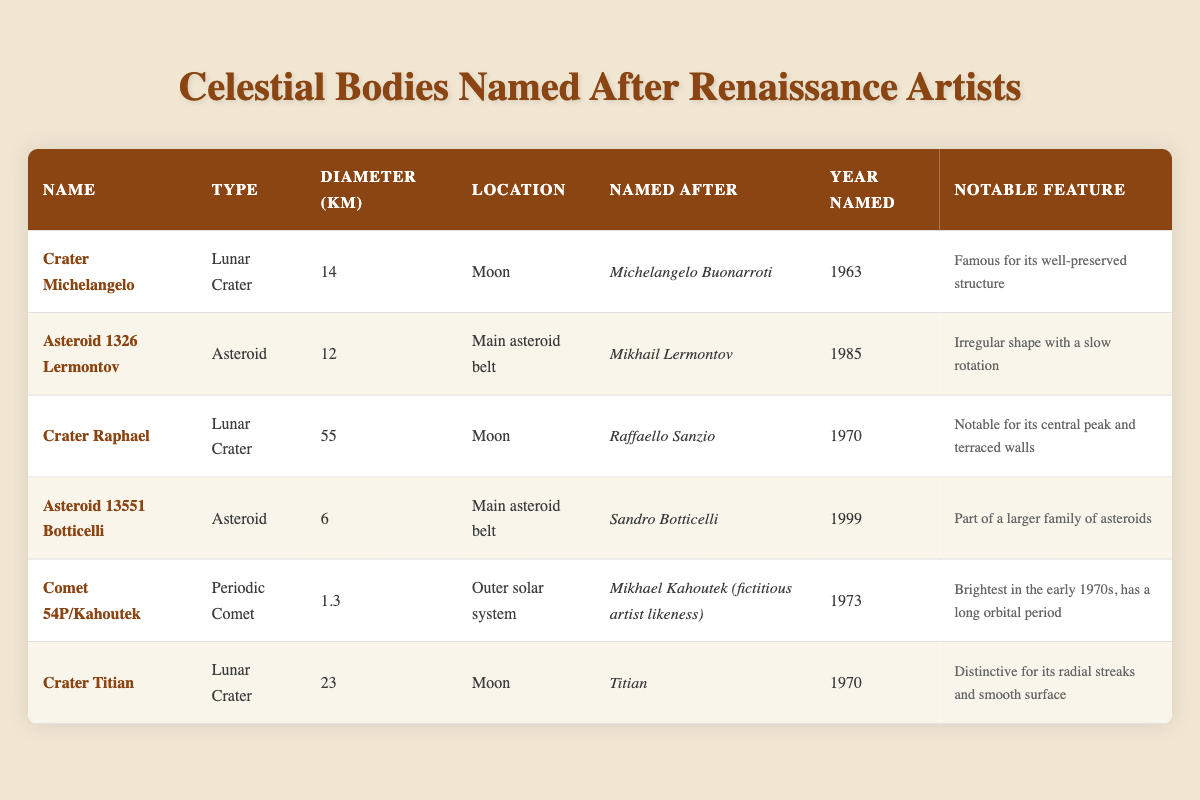What is the diameter of Crater Raphael? The table indicates the diameter of Crater Raphael is listed under the "Diameter (km)" column. Specifically, it shows a value of 55 km.
Answer: 55 km How many celestial bodies are named after artists with a first name starting with the letter 'M'? The table lists Crater Michelangelo and Asteroid 1326 Lermontov, both starting with 'M'. Therefore, there are two celestial bodies in total.
Answer: 2 What is the range of diameters for the lunar craters in the table? The lunar craters listed are Crater Michelangelo (14 km), Crater Raphael (55 km), Crater Titian (23 km). The range is calculated by subtracting the smallest diameter from the largest diameter: 55 km - 14 km = 41 km.
Answer: 41 km Did any of the celestial bodies named after artists have a notable feature describing a structure's preservation? Yes, Crater Michelangelo is described as "Famous for its well-preserved structure" in the notable feature column. This confirms the fact.
Answer: Yes What is the average diameter of the asteroids listed in the table? The asteroids are Asteroid 1326 Lermontov (12 km) and Asteroid 13551 Botticelli (6 km). To find the average, we sum their diameters: 12 km + 6 km = 18 km, then divide by the number of asteroids: 18 km / 2 = 9 km.
Answer: 9 km Are there any celestial bodies named after artists that have a notable feature related to their shape? Yes, Asteroid 1326 Lermontov is noted for being "Irregular shape with a slow rotation". Therefore, the answer is affirmative based on its description.
Answer: Yes Which celestial body was named in the earliest year? Looking at the "Year Named" column, Crater Michelangelo was named in 1963, which is earlier than any other entries. Therefore, it is the first.
Answer: Crater Michelangelo What is the total number of celestial bodies listed in the table? By counting the entries in the table, we find six celestial bodies (Crater Michelangelo, Asteroid 1326 Lermontov, Crater Raphael, Asteroid 13551 Botticelli, Comet 54P/Kahoutek, Crater Titian).
Answer: 6 